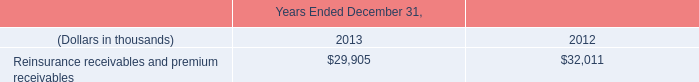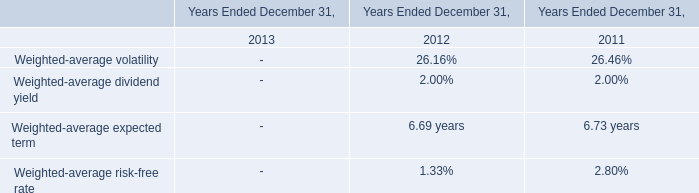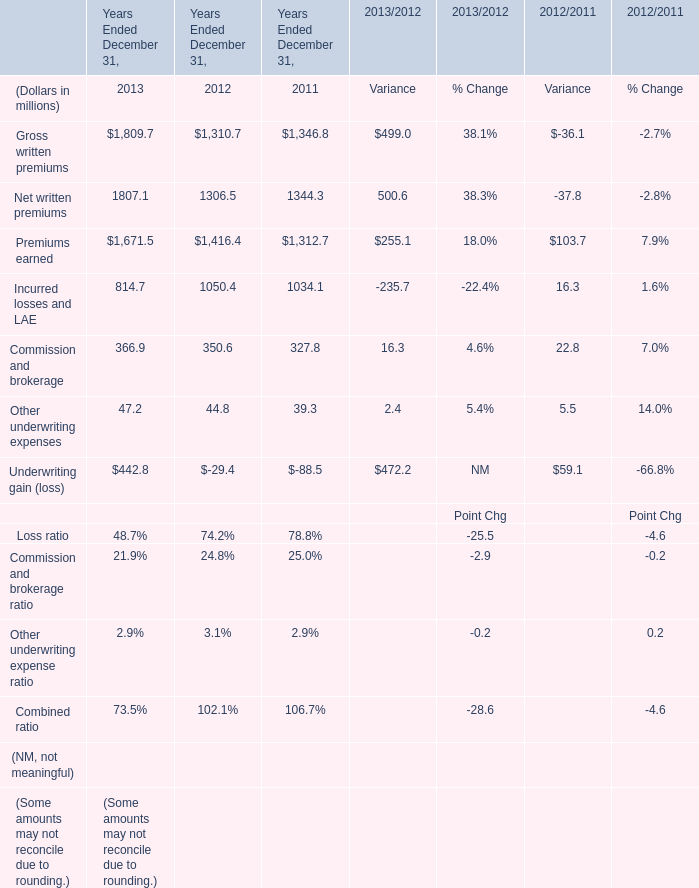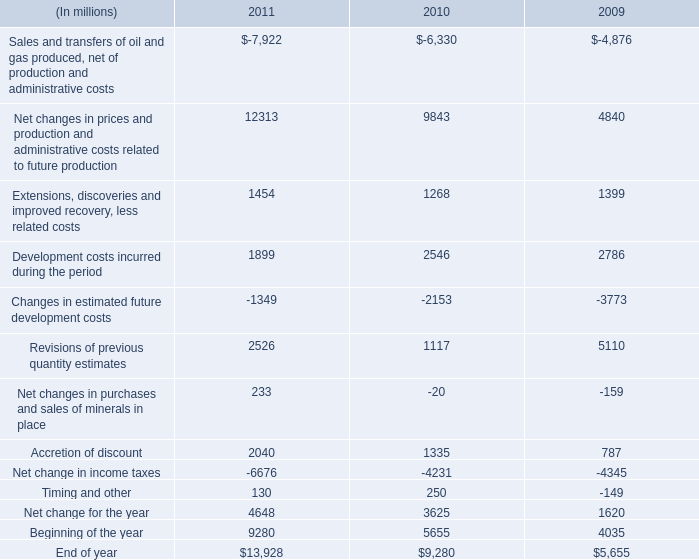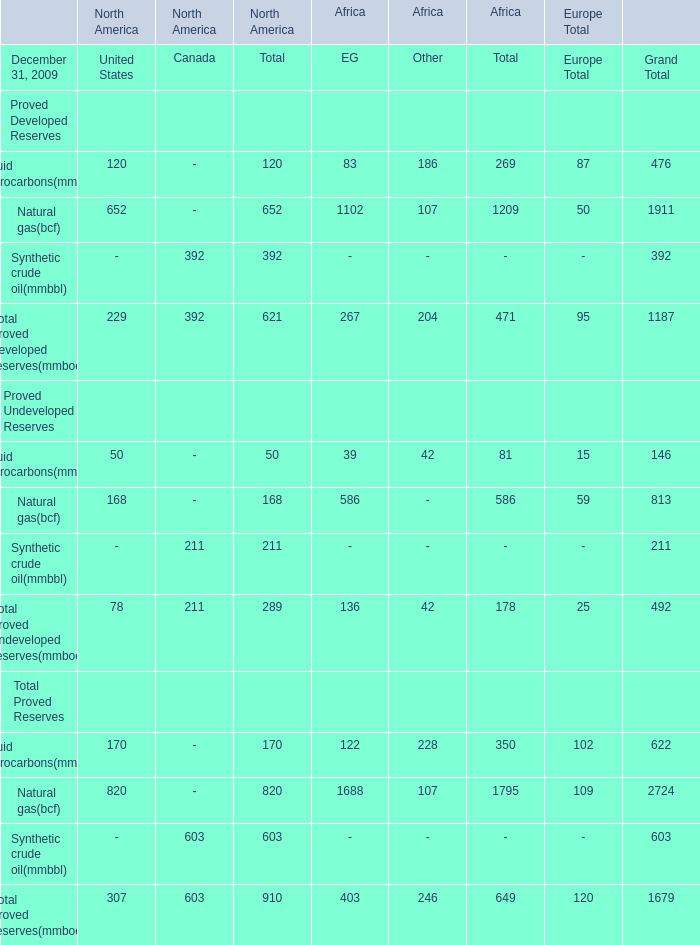What's the average of Net change in income taxes of 2011, and Gross written premiums of Years Ended December 31, 2013 ? 
Computations: ((6676.0 + 1809.7) / 2)
Answer: 4242.85. 